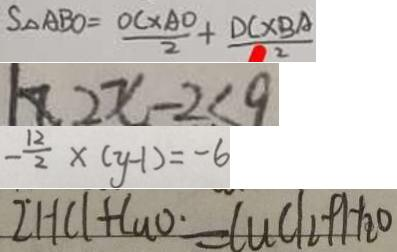Convert formula to latex. <formula><loc_0><loc_0><loc_500><loc_500>S _ { \Delta } A B O = \frac { O C \times A O } { 2 } + \frac { D C \times B A } { 2 } 
 2 x - 2 \leq 9 
 - \frac { 1 2 } { 2 } \times ( y - 1 ) = - 6 
 2 H C l + C u O \cdot = C u C l _ { 2 } + H _ { 2 } O</formula> 